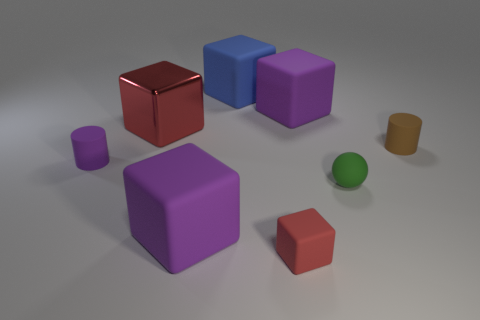How many spheres are large matte things or tiny shiny objects?
Provide a succinct answer. 0. There is a purple cube behind the rubber cylinder on the left side of the red object that is in front of the tiny matte sphere; what is its size?
Offer a terse response. Large. What is the shape of the purple object that is the same size as the red matte object?
Your answer should be very brief. Cylinder. The green matte object is what shape?
Provide a short and direct response. Sphere. Is the green object that is right of the tiny purple thing made of the same material as the large red cube?
Your answer should be very brief. No. There is a red block that is behind the object on the right side of the tiny matte sphere; how big is it?
Ensure brevity in your answer.  Large. What is the color of the block that is behind the tiny purple thing and left of the big blue object?
Provide a short and direct response. Red. What material is the blue object that is the same size as the red shiny block?
Your response must be concise. Rubber. How many other things are made of the same material as the small purple cylinder?
Provide a succinct answer. 6. Is the color of the big matte block that is in front of the small purple object the same as the small cylinder on the left side of the tiny green rubber ball?
Ensure brevity in your answer.  Yes. 